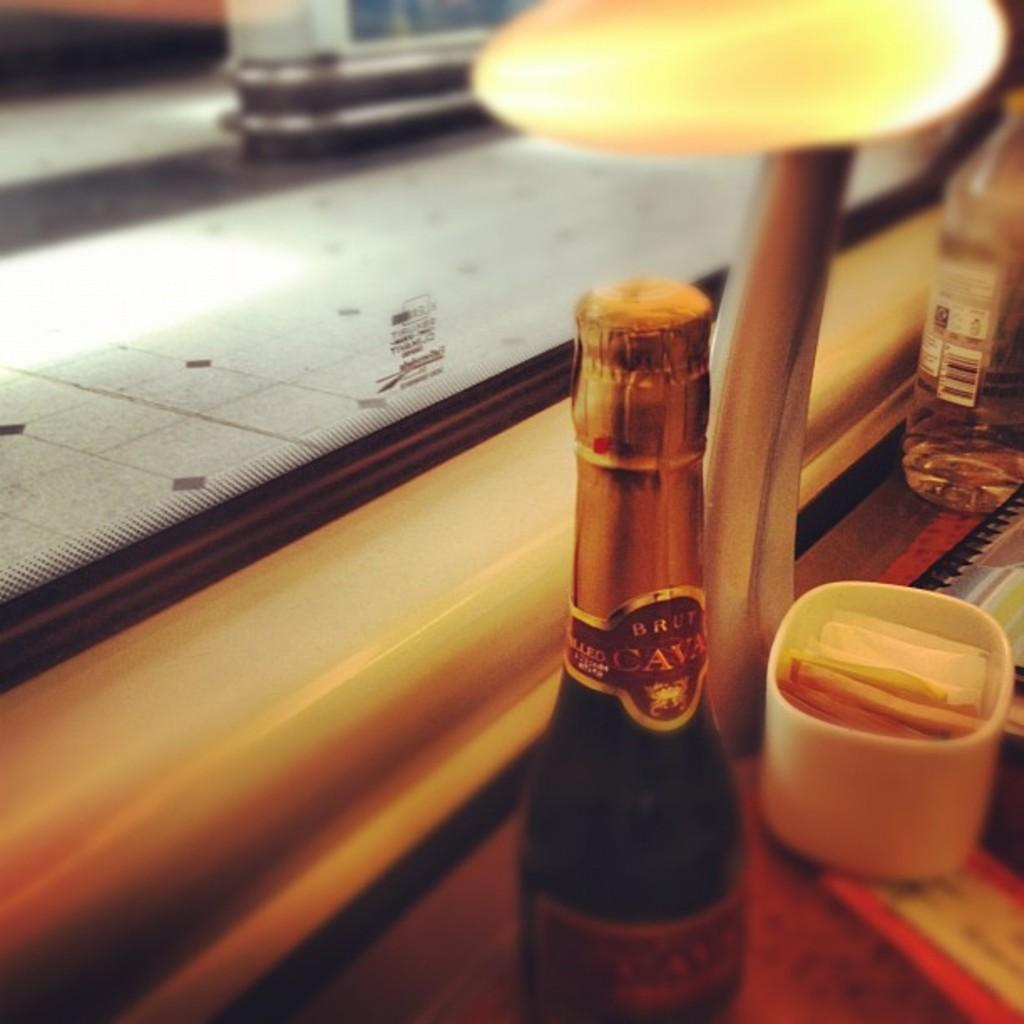Provide a one-sentence caption for the provided image. A small bottle of wine says CAVA on the foil wrapper around the neck. 